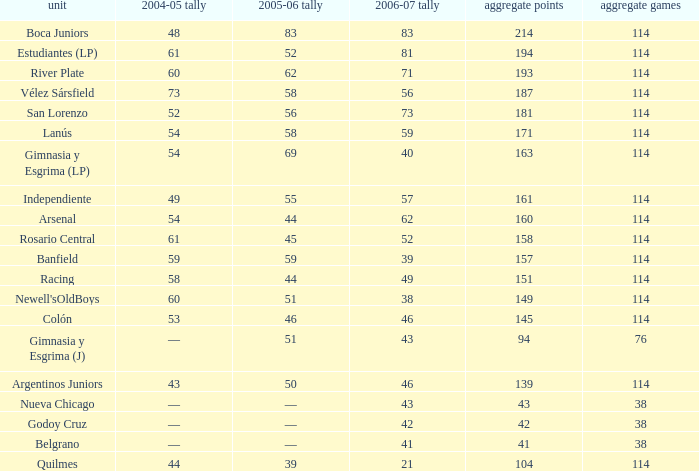What is the combined amount of points for a total pld under 38? 0.0. 